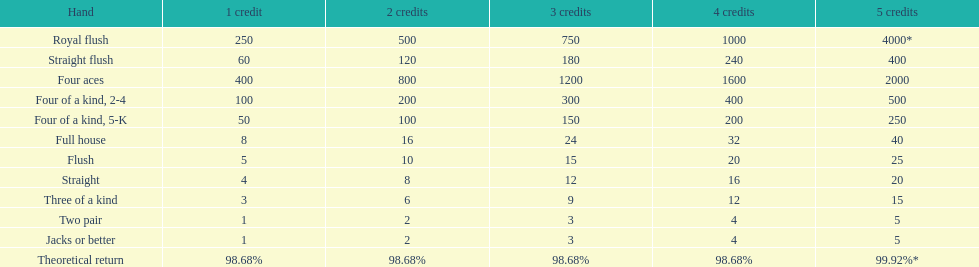What values can be found in the area of 5 credits? 4000*, 400, 2000, 500, 250, 40, 25, 20, 15, 5, 5. Which one is designated for a four of a kind? 500, 250. What is the highest value? 500. What hand does this refer to? Four of a kind, 2-4. 